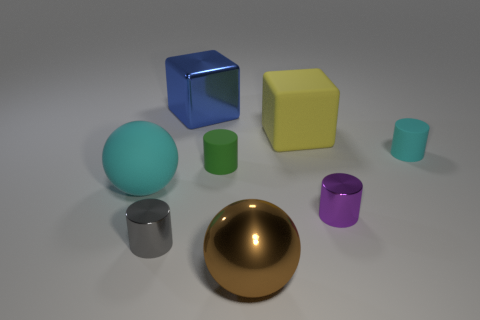What number of yellow objects are the same shape as the big blue shiny object? There is 1 yellow object that shares the same cube shape as the big blue shiny object. 